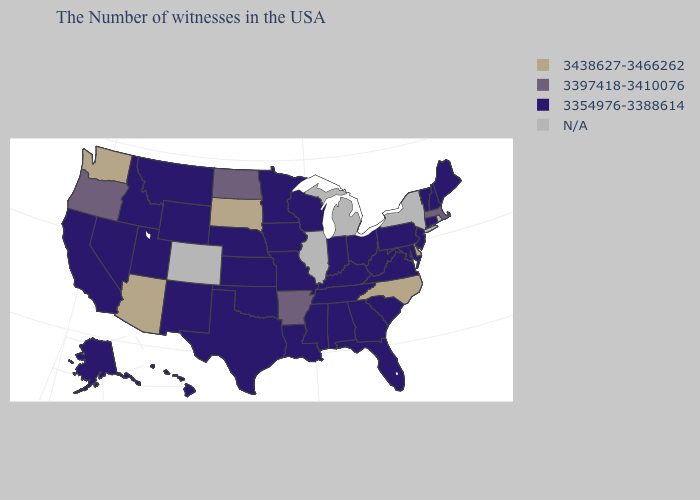Name the states that have a value in the range 3397418-3410076?
Short answer required. Massachusetts, Arkansas, North Dakota, Oregon. Name the states that have a value in the range 3397418-3410076?
Concise answer only. Massachusetts, Arkansas, North Dakota, Oregon. Is the legend a continuous bar?
Be succinct. No. Among the states that border Utah , which have the highest value?
Give a very brief answer. Arizona. Name the states that have a value in the range 3397418-3410076?
Concise answer only. Massachusetts, Arkansas, North Dakota, Oregon. What is the value of Kentucky?
Short answer required. 3354976-3388614. What is the highest value in the USA?
Quick response, please. 3438627-3466262. Name the states that have a value in the range 3397418-3410076?
Write a very short answer. Massachusetts, Arkansas, North Dakota, Oregon. Which states have the lowest value in the USA?
Be succinct. Maine, New Hampshire, Vermont, Connecticut, New Jersey, Maryland, Pennsylvania, Virginia, South Carolina, West Virginia, Ohio, Florida, Georgia, Kentucky, Indiana, Alabama, Tennessee, Wisconsin, Mississippi, Louisiana, Missouri, Minnesota, Iowa, Kansas, Nebraska, Oklahoma, Texas, Wyoming, New Mexico, Utah, Montana, Idaho, Nevada, California, Alaska, Hawaii. Name the states that have a value in the range 3438627-3466262?
Give a very brief answer. Delaware, North Carolina, South Dakota, Arizona, Washington. What is the value of Tennessee?
Give a very brief answer. 3354976-3388614. What is the value of North Dakota?
Keep it brief. 3397418-3410076. Among the states that border Maryland , which have the highest value?
Answer briefly. Delaware. Does Nebraska have the lowest value in the MidWest?
Concise answer only. Yes. 